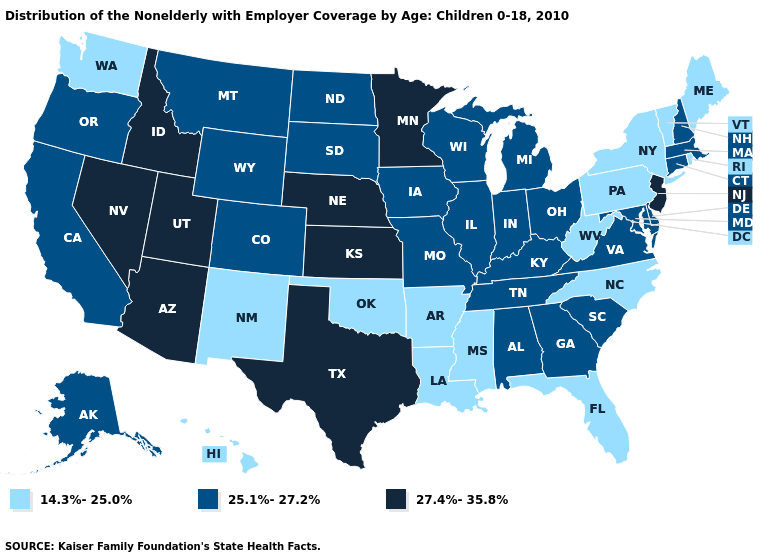Name the states that have a value in the range 25.1%-27.2%?
Give a very brief answer. Alabama, Alaska, California, Colorado, Connecticut, Delaware, Georgia, Illinois, Indiana, Iowa, Kentucky, Maryland, Massachusetts, Michigan, Missouri, Montana, New Hampshire, North Dakota, Ohio, Oregon, South Carolina, South Dakota, Tennessee, Virginia, Wisconsin, Wyoming. Which states have the lowest value in the USA?
Quick response, please. Arkansas, Florida, Hawaii, Louisiana, Maine, Mississippi, New Mexico, New York, North Carolina, Oklahoma, Pennsylvania, Rhode Island, Vermont, Washington, West Virginia. Name the states that have a value in the range 25.1%-27.2%?
Concise answer only. Alabama, Alaska, California, Colorado, Connecticut, Delaware, Georgia, Illinois, Indiana, Iowa, Kentucky, Maryland, Massachusetts, Michigan, Missouri, Montana, New Hampshire, North Dakota, Ohio, Oregon, South Carolina, South Dakota, Tennessee, Virginia, Wisconsin, Wyoming. What is the value of Arizona?
Answer briefly. 27.4%-35.8%. Name the states that have a value in the range 25.1%-27.2%?
Keep it brief. Alabama, Alaska, California, Colorado, Connecticut, Delaware, Georgia, Illinois, Indiana, Iowa, Kentucky, Maryland, Massachusetts, Michigan, Missouri, Montana, New Hampshire, North Dakota, Ohio, Oregon, South Carolina, South Dakota, Tennessee, Virginia, Wisconsin, Wyoming. What is the lowest value in the USA?
Quick response, please. 14.3%-25.0%. What is the highest value in the South ?
Write a very short answer. 27.4%-35.8%. Which states have the lowest value in the MidWest?
Concise answer only. Illinois, Indiana, Iowa, Michigan, Missouri, North Dakota, Ohio, South Dakota, Wisconsin. Does the first symbol in the legend represent the smallest category?
Concise answer only. Yes. What is the value of North Dakota?
Write a very short answer. 25.1%-27.2%. Does the map have missing data?
Concise answer only. No. What is the highest value in the MidWest ?
Write a very short answer. 27.4%-35.8%. Does Michigan have the same value as Missouri?
Be succinct. Yes. Among the states that border Arkansas , which have the lowest value?
Write a very short answer. Louisiana, Mississippi, Oklahoma. What is the value of California?
Quick response, please. 25.1%-27.2%. 